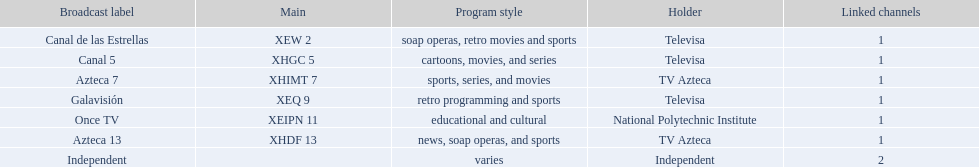What stations show sports? Soap operas, retro movies and sports, retro programming and sports, news, soap operas, and sports. What of these is not affiliated with televisa? Azteca 7. 